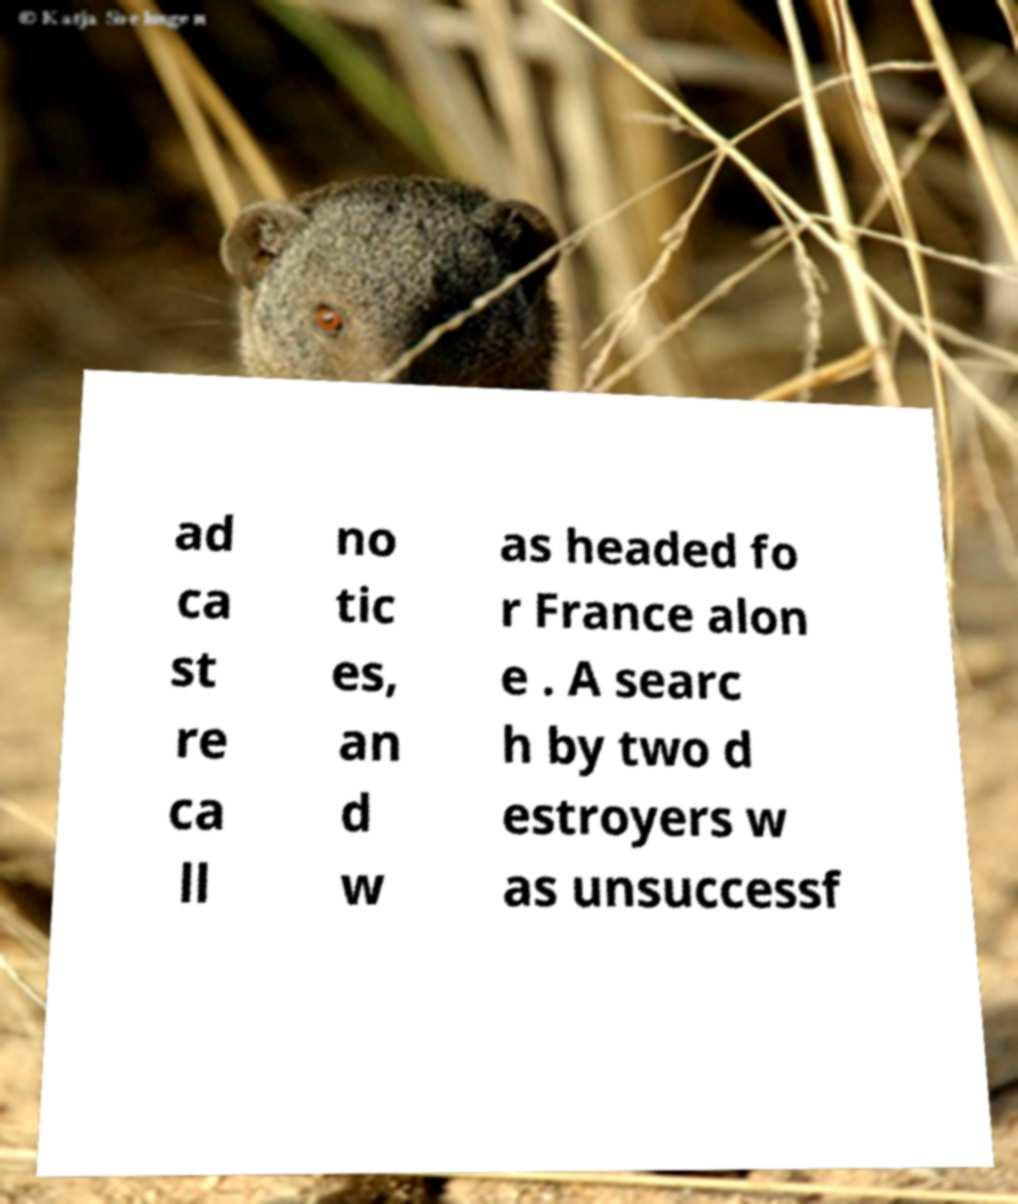What messages or text are displayed in this image? I need them in a readable, typed format. ad ca st re ca ll no tic es, an d w as headed fo r France alon e . A searc h by two d estroyers w as unsuccessf 